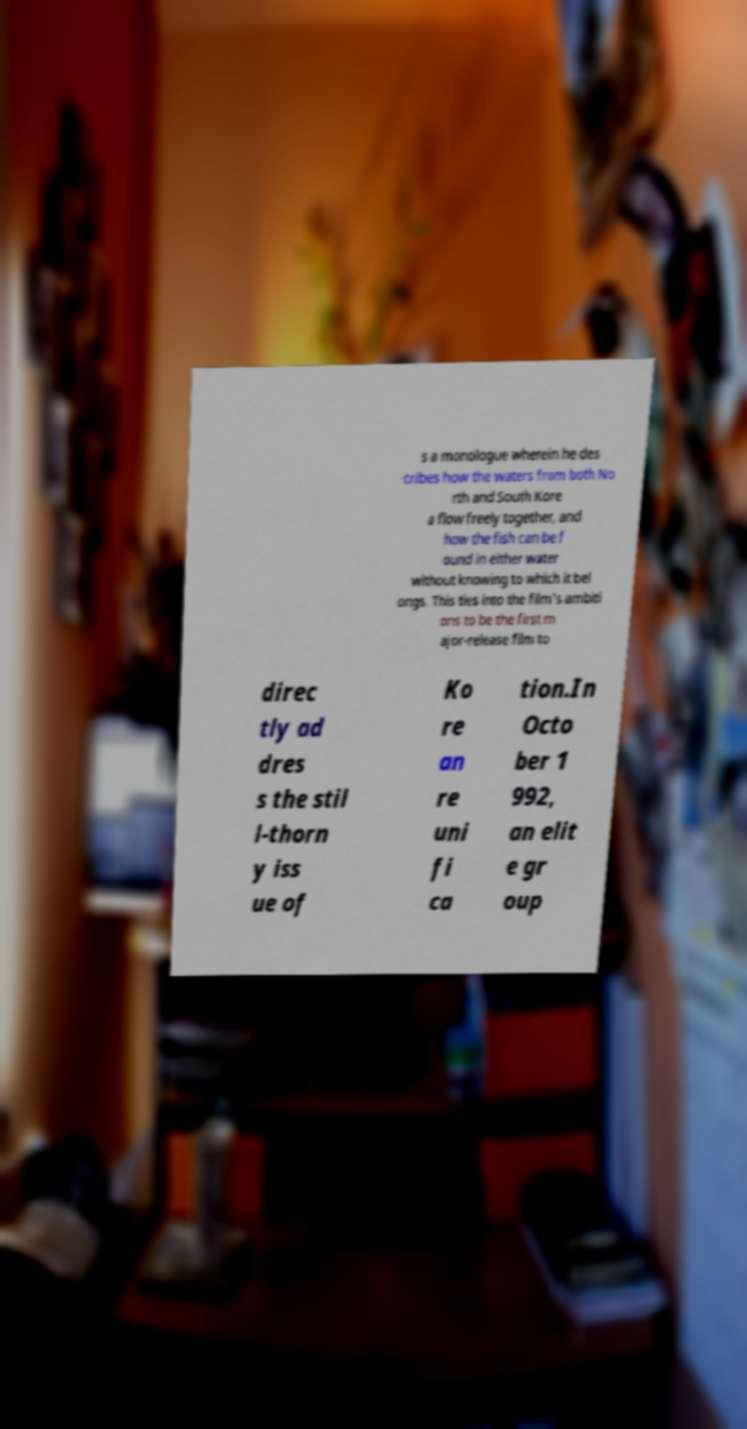What messages or text are displayed in this image? I need them in a readable, typed format. s a monologue wherein he des cribes how the waters from both No rth and South Kore a flow freely together, and how the fish can be f ound in either water without knowing to which it bel ongs. This ties into the film's ambiti ons to be the first m ajor-release film to direc tly ad dres s the stil l-thorn y iss ue of Ko re an re uni fi ca tion.In Octo ber 1 992, an elit e gr oup 